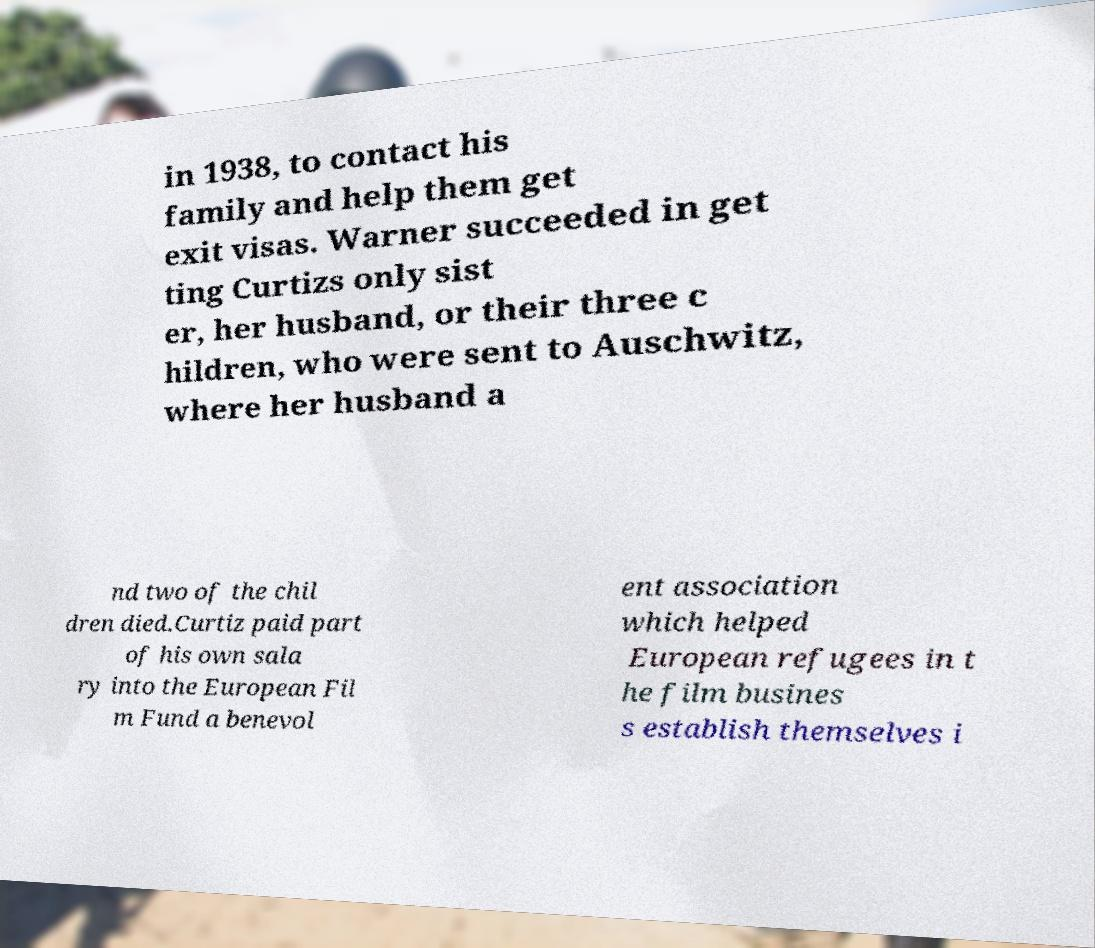Can you accurately transcribe the text from the provided image for me? in 1938, to contact his family and help them get exit visas. Warner succeeded in get ting Curtizs only sist er, her husband, or their three c hildren, who were sent to Auschwitz, where her husband a nd two of the chil dren died.Curtiz paid part of his own sala ry into the European Fil m Fund a benevol ent association which helped European refugees in t he film busines s establish themselves i 